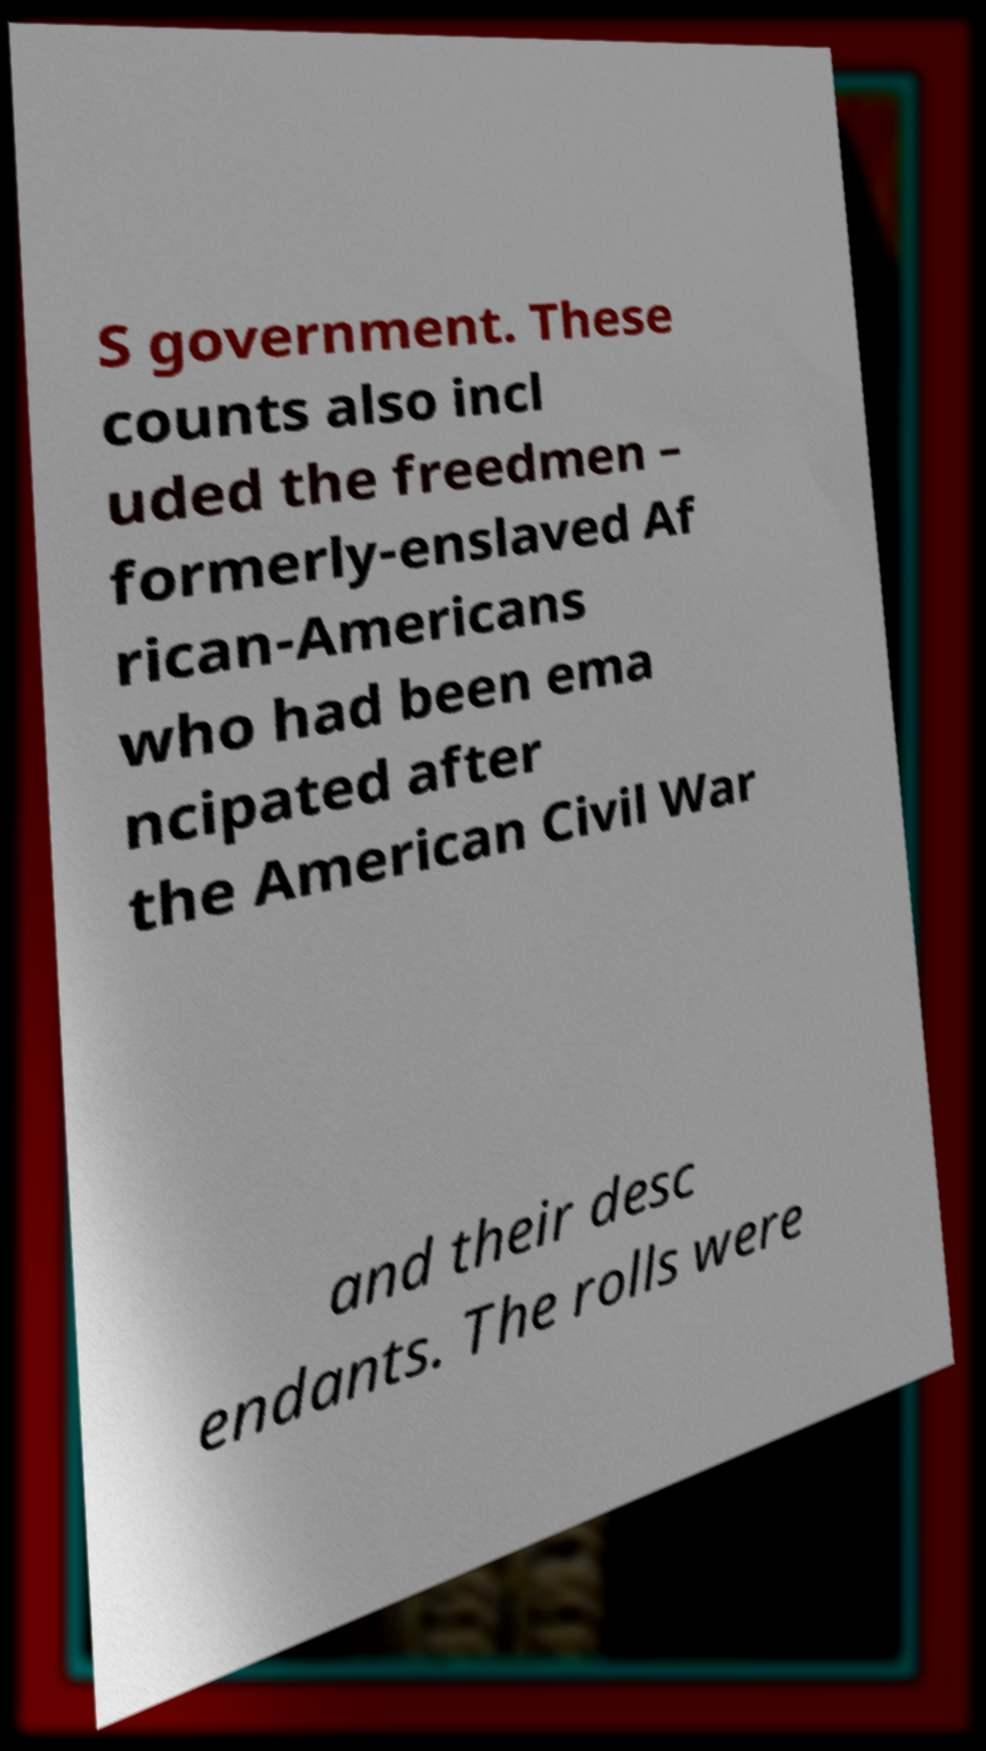Could you assist in decoding the text presented in this image and type it out clearly? S government. These counts also incl uded the freedmen – formerly-enslaved Af rican-Americans who had been ema ncipated after the American Civil War and their desc endants. The rolls were 